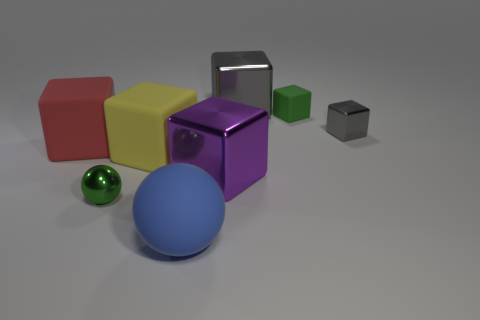Is there anything else that is the same shape as the blue thing?
Your answer should be compact. Yes. Is the gray thing that is in front of the small green rubber cube made of the same material as the small green thing that is on the right side of the small sphere?
Your response must be concise. No. What is the material of the small gray object?
Make the answer very short. Metal. What number of big blue spheres are the same material as the large red cube?
Make the answer very short. 1. What number of metal objects are either small cyan balls or large balls?
Keep it short and to the point. 0. There is a large metallic thing in front of the big red object; does it have the same shape as the blue matte object that is in front of the large yellow rubber thing?
Make the answer very short. No. There is a shiny block that is to the left of the small shiny cube and to the right of the large purple thing; what color is it?
Your response must be concise. Gray. Does the metal object to the left of the matte sphere have the same size as the green thing that is right of the large blue object?
Provide a succinct answer. Yes. How many other blocks are the same color as the small metal block?
Keep it short and to the point. 1. What number of tiny things are yellow balls or green spheres?
Your answer should be very brief. 1. 